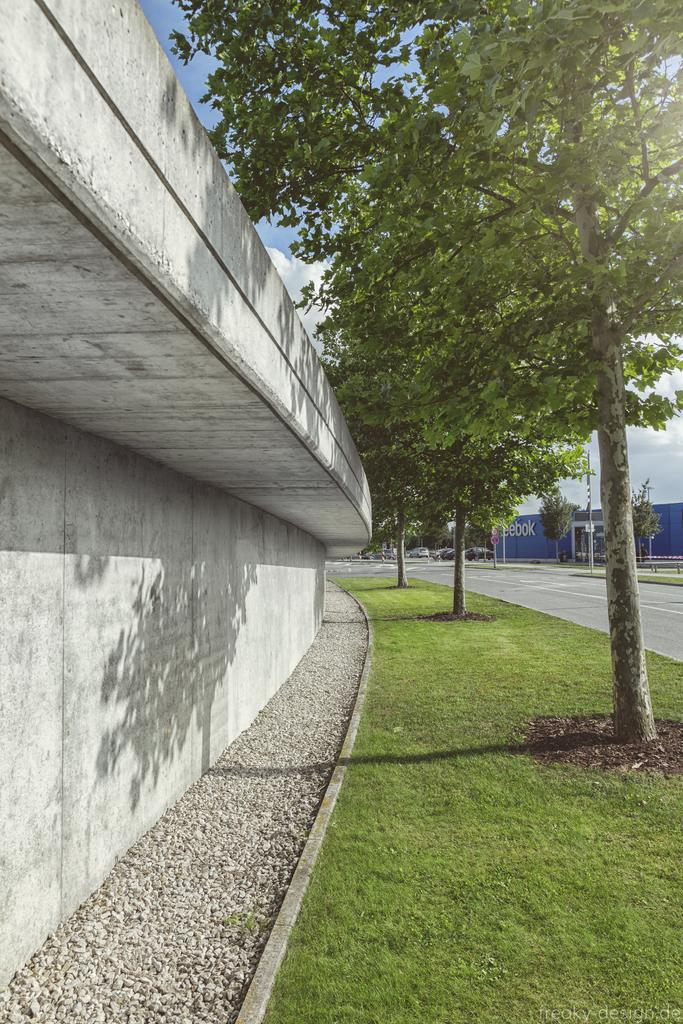What type of structure can be seen in the image? There is a wall in the image. What type of natural environment is visible in the image? There is grass, trees, and the sky visible in the image. What type of man-made environment is visible in the image? There is a road and a pole visible in the image. What type of transportation is present in the image? There are vehicles in the image. Can you see a pan being used to cook in the image? There is no pan visible in the image. Are there any people in the image kicking a ball? There are no people or any ball visible in the image. 